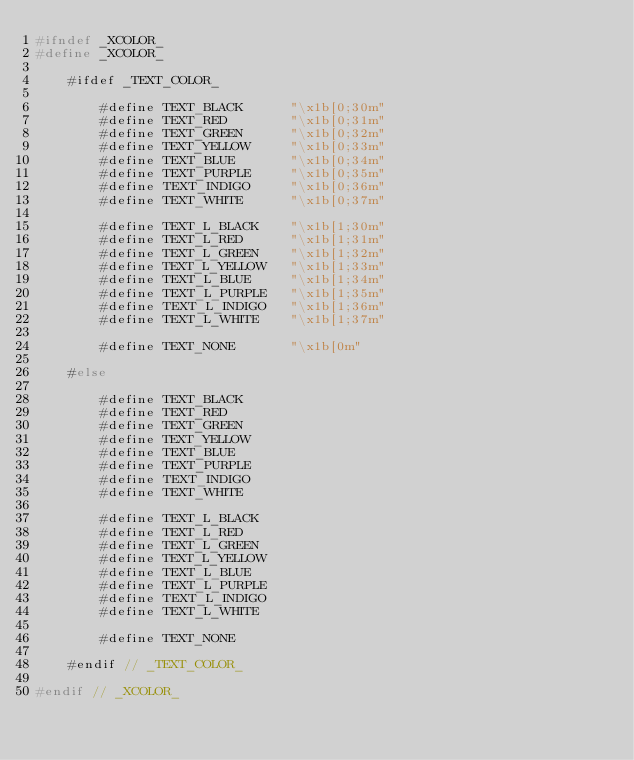<code> <loc_0><loc_0><loc_500><loc_500><_C_>#ifndef _XCOLOR_
#define _XCOLOR_

    #ifdef _TEXT_COLOR_

        #define TEXT_BLACK      "\x1b[0;30m"
        #define TEXT_RED        "\x1b[0;31m"
        #define TEXT_GREEN      "\x1b[0;32m"
        #define TEXT_YELLOW     "\x1b[0;33m"
        #define TEXT_BLUE       "\x1b[0;34m"
        #define TEXT_PURPLE     "\x1b[0;35m"
        #define TEXT_INDIGO     "\x1b[0;36m"
        #define TEXT_WHITE      "\x1b[0;37m"

        #define TEXT_L_BLACK    "\x1b[1;30m"
        #define TEXT_L_RED      "\x1b[1;31m"
        #define TEXT_L_GREEN    "\x1b[1;32m"
        #define TEXT_L_YELLOW   "\x1b[1;33m"
        #define TEXT_L_BLUE     "\x1b[1;34m"
        #define TEXT_L_PURPLE   "\x1b[1;35m"
        #define TEXT_L_INDIGO   "\x1b[1;36m"
        #define TEXT_L_WHITE    "\x1b[1;37m"

        #define TEXT_NONE       "\x1b[0m"

    #else

        #define TEXT_BLACK
        #define TEXT_RED
        #define TEXT_GREEN
        #define TEXT_YELLOW
        #define TEXT_BLUE
        #define TEXT_PURPLE
        #define TEXT_INDIGO
        #define TEXT_WHITE

        #define TEXT_L_BLACK
        #define TEXT_L_RED
        #define TEXT_L_GREEN
        #define TEXT_L_YELLOW
        #define TEXT_L_BLUE
        #define TEXT_L_PURPLE
        #define TEXT_L_INDIGO
        #define TEXT_L_WHITE

        #define TEXT_NONE

    #endif // _TEXT_COLOR_

#endif // _XCOLOR_
</code> 